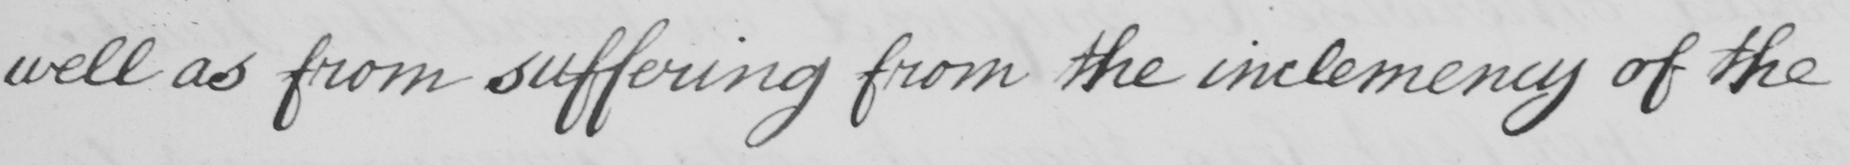What text is written in this handwritten line? well as from suffering from the inclemency of the 